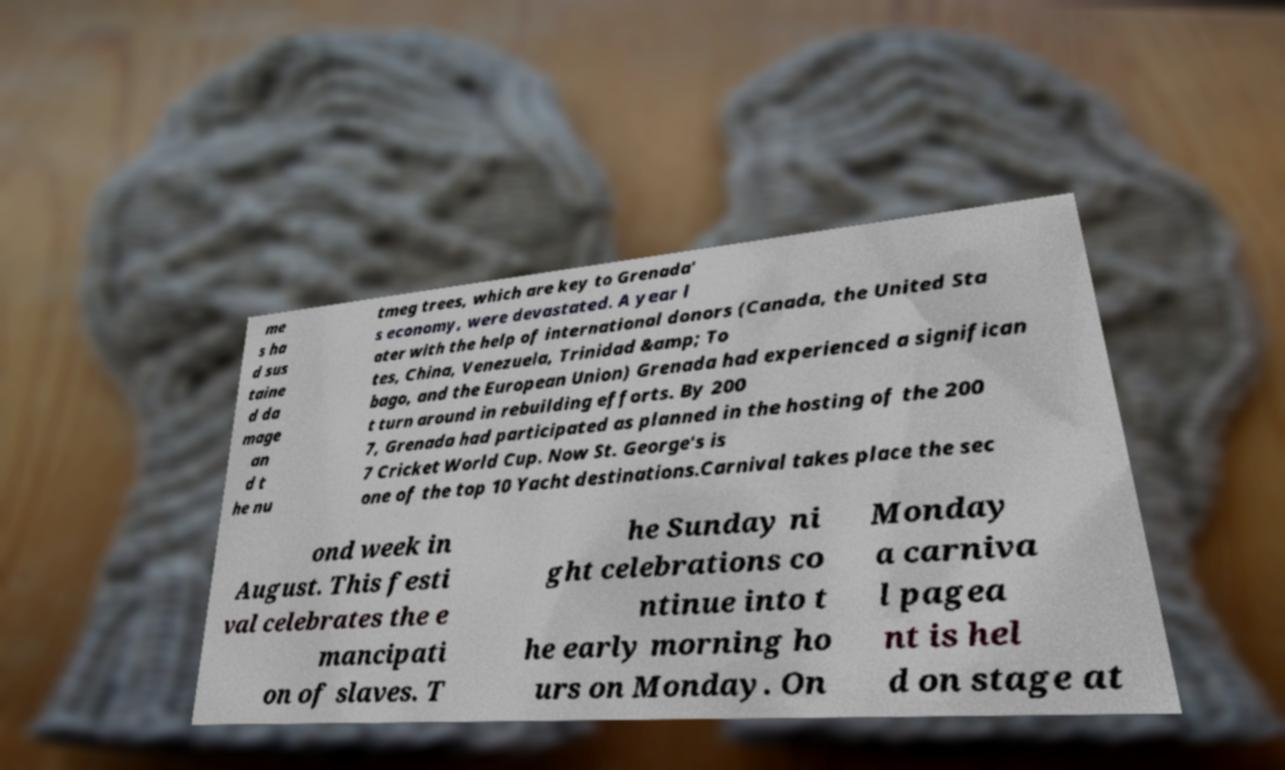Can you read and provide the text displayed in the image?This photo seems to have some interesting text. Can you extract and type it out for me? me s ha d sus taine d da mage an d t he nu tmeg trees, which are key to Grenada' s economy, were devastated. A year l ater with the help of international donors (Canada, the United Sta tes, China, Venezuela, Trinidad &amp; To bago, and the European Union) Grenada had experienced a significan t turn around in rebuilding efforts. By 200 7, Grenada had participated as planned in the hosting of the 200 7 Cricket World Cup. Now St. George's is one of the top 10 Yacht destinations.Carnival takes place the sec ond week in August. This festi val celebrates the e mancipati on of slaves. T he Sunday ni ght celebrations co ntinue into t he early morning ho urs on Monday. On Monday a carniva l pagea nt is hel d on stage at 